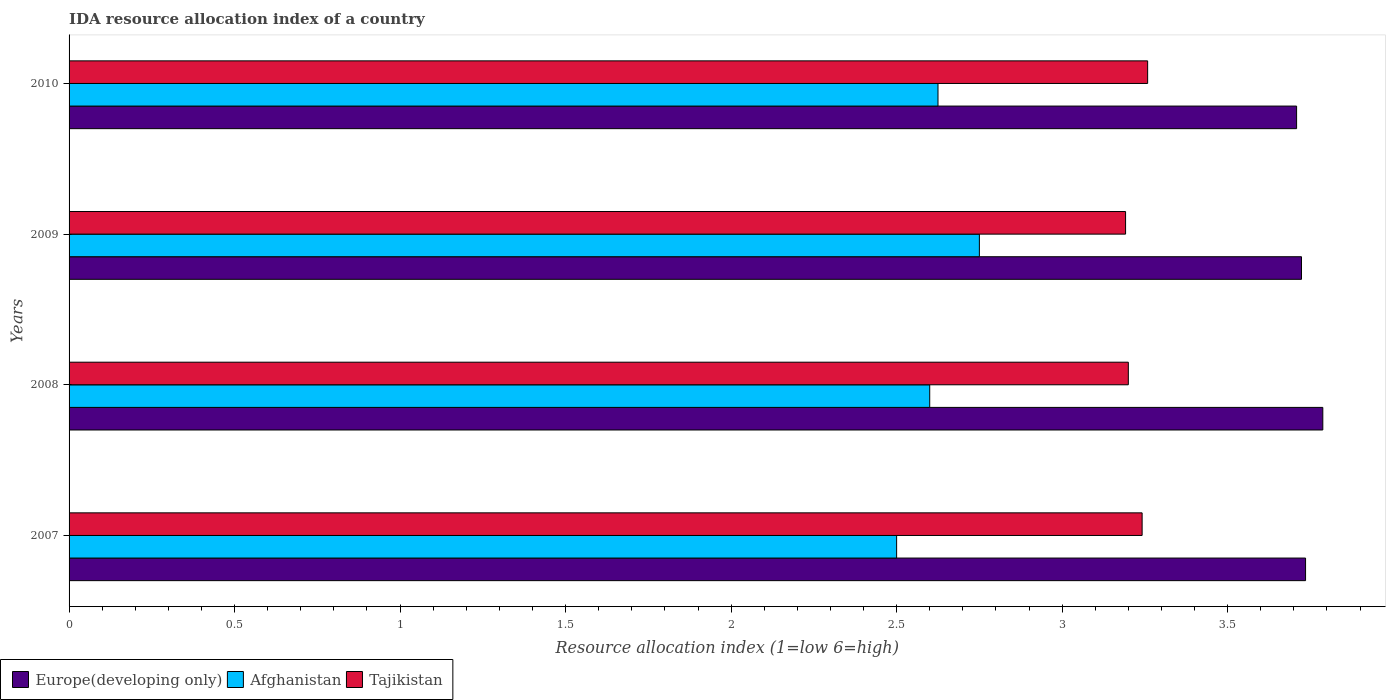How many bars are there on the 4th tick from the top?
Provide a succinct answer. 3. What is the IDA resource allocation index in Afghanistan in 2010?
Offer a very short reply. 2.62. Across all years, what is the maximum IDA resource allocation index in Tajikistan?
Keep it short and to the point. 3.26. In which year was the IDA resource allocation index in Europe(developing only) maximum?
Make the answer very short. 2008. In which year was the IDA resource allocation index in Europe(developing only) minimum?
Make the answer very short. 2010. What is the total IDA resource allocation index in Europe(developing only) in the graph?
Offer a very short reply. 14.95. What is the difference between the IDA resource allocation index in Europe(developing only) in 2007 and that in 2010?
Make the answer very short. 0.03. What is the difference between the IDA resource allocation index in Europe(developing only) in 2009 and the IDA resource allocation index in Tajikistan in 2008?
Give a very brief answer. 0.52. What is the average IDA resource allocation index in Europe(developing only) per year?
Give a very brief answer. 3.74. In the year 2007, what is the difference between the IDA resource allocation index in Tajikistan and IDA resource allocation index in Europe(developing only)?
Your answer should be compact. -0.49. In how many years, is the IDA resource allocation index in Afghanistan greater than 0.30000000000000004 ?
Keep it short and to the point. 4. What is the ratio of the IDA resource allocation index in Europe(developing only) in 2008 to that in 2009?
Provide a short and direct response. 1.02. Is the IDA resource allocation index in Tajikistan in 2008 less than that in 2009?
Provide a short and direct response. No. Is the difference between the IDA resource allocation index in Tajikistan in 2008 and 2010 greater than the difference between the IDA resource allocation index in Europe(developing only) in 2008 and 2010?
Your answer should be compact. No. What is the difference between the highest and the second highest IDA resource allocation index in Tajikistan?
Ensure brevity in your answer.  0.02. What is the difference between the highest and the lowest IDA resource allocation index in Europe(developing only)?
Make the answer very short. 0.08. In how many years, is the IDA resource allocation index in Afghanistan greater than the average IDA resource allocation index in Afghanistan taken over all years?
Give a very brief answer. 2. What does the 1st bar from the top in 2008 represents?
Your response must be concise. Tajikistan. What does the 2nd bar from the bottom in 2010 represents?
Your response must be concise. Afghanistan. Is it the case that in every year, the sum of the IDA resource allocation index in Tajikistan and IDA resource allocation index in Afghanistan is greater than the IDA resource allocation index in Europe(developing only)?
Your answer should be compact. Yes. How many bars are there?
Offer a very short reply. 12. Are all the bars in the graph horizontal?
Provide a short and direct response. Yes. How are the legend labels stacked?
Offer a very short reply. Horizontal. What is the title of the graph?
Keep it short and to the point. IDA resource allocation index of a country. Does "Australia" appear as one of the legend labels in the graph?
Offer a very short reply. No. What is the label or title of the X-axis?
Your answer should be very brief. Resource allocation index (1=low 6=high). What is the Resource allocation index (1=low 6=high) of Europe(developing only) in 2007?
Your response must be concise. 3.74. What is the Resource allocation index (1=low 6=high) of Tajikistan in 2007?
Provide a succinct answer. 3.24. What is the Resource allocation index (1=low 6=high) of Europe(developing only) in 2008?
Offer a very short reply. 3.79. What is the Resource allocation index (1=low 6=high) in Afghanistan in 2008?
Make the answer very short. 2.6. What is the Resource allocation index (1=low 6=high) of Europe(developing only) in 2009?
Offer a terse response. 3.72. What is the Resource allocation index (1=low 6=high) of Afghanistan in 2009?
Provide a succinct answer. 2.75. What is the Resource allocation index (1=low 6=high) of Tajikistan in 2009?
Provide a succinct answer. 3.19. What is the Resource allocation index (1=low 6=high) in Europe(developing only) in 2010?
Your answer should be compact. 3.71. What is the Resource allocation index (1=low 6=high) of Afghanistan in 2010?
Your answer should be compact. 2.62. What is the Resource allocation index (1=low 6=high) of Tajikistan in 2010?
Ensure brevity in your answer.  3.26. Across all years, what is the maximum Resource allocation index (1=low 6=high) of Europe(developing only)?
Ensure brevity in your answer.  3.79. Across all years, what is the maximum Resource allocation index (1=low 6=high) of Afghanistan?
Your response must be concise. 2.75. Across all years, what is the maximum Resource allocation index (1=low 6=high) of Tajikistan?
Your answer should be very brief. 3.26. Across all years, what is the minimum Resource allocation index (1=low 6=high) in Europe(developing only)?
Offer a very short reply. 3.71. Across all years, what is the minimum Resource allocation index (1=low 6=high) in Afghanistan?
Your response must be concise. 2.5. Across all years, what is the minimum Resource allocation index (1=low 6=high) in Tajikistan?
Keep it short and to the point. 3.19. What is the total Resource allocation index (1=low 6=high) of Europe(developing only) in the graph?
Make the answer very short. 14.95. What is the total Resource allocation index (1=low 6=high) of Afghanistan in the graph?
Offer a very short reply. 10.47. What is the total Resource allocation index (1=low 6=high) in Tajikistan in the graph?
Keep it short and to the point. 12.89. What is the difference between the Resource allocation index (1=low 6=high) in Europe(developing only) in 2007 and that in 2008?
Your answer should be compact. -0.05. What is the difference between the Resource allocation index (1=low 6=high) of Afghanistan in 2007 and that in 2008?
Your answer should be very brief. -0.1. What is the difference between the Resource allocation index (1=low 6=high) of Tajikistan in 2007 and that in 2008?
Your response must be concise. 0.04. What is the difference between the Resource allocation index (1=low 6=high) of Europe(developing only) in 2007 and that in 2009?
Provide a succinct answer. 0.01. What is the difference between the Resource allocation index (1=low 6=high) of Afghanistan in 2007 and that in 2009?
Provide a succinct answer. -0.25. What is the difference between the Resource allocation index (1=low 6=high) in Europe(developing only) in 2007 and that in 2010?
Provide a succinct answer. 0.03. What is the difference between the Resource allocation index (1=low 6=high) of Afghanistan in 2007 and that in 2010?
Ensure brevity in your answer.  -0.12. What is the difference between the Resource allocation index (1=low 6=high) in Tajikistan in 2007 and that in 2010?
Ensure brevity in your answer.  -0.02. What is the difference between the Resource allocation index (1=low 6=high) in Europe(developing only) in 2008 and that in 2009?
Your answer should be very brief. 0.06. What is the difference between the Resource allocation index (1=low 6=high) in Tajikistan in 2008 and that in 2009?
Offer a very short reply. 0.01. What is the difference between the Resource allocation index (1=low 6=high) in Europe(developing only) in 2008 and that in 2010?
Make the answer very short. 0.08. What is the difference between the Resource allocation index (1=low 6=high) of Afghanistan in 2008 and that in 2010?
Offer a very short reply. -0.03. What is the difference between the Resource allocation index (1=low 6=high) of Tajikistan in 2008 and that in 2010?
Ensure brevity in your answer.  -0.06. What is the difference between the Resource allocation index (1=low 6=high) in Europe(developing only) in 2009 and that in 2010?
Offer a terse response. 0.01. What is the difference between the Resource allocation index (1=low 6=high) of Tajikistan in 2009 and that in 2010?
Offer a terse response. -0.07. What is the difference between the Resource allocation index (1=low 6=high) of Europe(developing only) in 2007 and the Resource allocation index (1=low 6=high) of Afghanistan in 2008?
Make the answer very short. 1.14. What is the difference between the Resource allocation index (1=low 6=high) in Europe(developing only) in 2007 and the Resource allocation index (1=low 6=high) in Tajikistan in 2008?
Your answer should be very brief. 0.54. What is the difference between the Resource allocation index (1=low 6=high) of Afghanistan in 2007 and the Resource allocation index (1=low 6=high) of Tajikistan in 2008?
Give a very brief answer. -0.7. What is the difference between the Resource allocation index (1=low 6=high) in Europe(developing only) in 2007 and the Resource allocation index (1=low 6=high) in Afghanistan in 2009?
Provide a short and direct response. 0.99. What is the difference between the Resource allocation index (1=low 6=high) of Europe(developing only) in 2007 and the Resource allocation index (1=low 6=high) of Tajikistan in 2009?
Your answer should be compact. 0.54. What is the difference between the Resource allocation index (1=low 6=high) of Afghanistan in 2007 and the Resource allocation index (1=low 6=high) of Tajikistan in 2009?
Your response must be concise. -0.69. What is the difference between the Resource allocation index (1=low 6=high) in Europe(developing only) in 2007 and the Resource allocation index (1=low 6=high) in Afghanistan in 2010?
Your answer should be compact. 1.11. What is the difference between the Resource allocation index (1=low 6=high) of Europe(developing only) in 2007 and the Resource allocation index (1=low 6=high) of Tajikistan in 2010?
Offer a very short reply. 0.48. What is the difference between the Resource allocation index (1=low 6=high) in Afghanistan in 2007 and the Resource allocation index (1=low 6=high) in Tajikistan in 2010?
Your answer should be compact. -0.76. What is the difference between the Resource allocation index (1=low 6=high) of Europe(developing only) in 2008 and the Resource allocation index (1=low 6=high) of Afghanistan in 2009?
Make the answer very short. 1.04. What is the difference between the Resource allocation index (1=low 6=high) of Europe(developing only) in 2008 and the Resource allocation index (1=low 6=high) of Tajikistan in 2009?
Offer a very short reply. 0.6. What is the difference between the Resource allocation index (1=low 6=high) in Afghanistan in 2008 and the Resource allocation index (1=low 6=high) in Tajikistan in 2009?
Your answer should be very brief. -0.59. What is the difference between the Resource allocation index (1=low 6=high) in Europe(developing only) in 2008 and the Resource allocation index (1=low 6=high) in Afghanistan in 2010?
Keep it short and to the point. 1.16. What is the difference between the Resource allocation index (1=low 6=high) of Europe(developing only) in 2008 and the Resource allocation index (1=low 6=high) of Tajikistan in 2010?
Ensure brevity in your answer.  0.53. What is the difference between the Resource allocation index (1=low 6=high) of Afghanistan in 2008 and the Resource allocation index (1=low 6=high) of Tajikistan in 2010?
Ensure brevity in your answer.  -0.66. What is the difference between the Resource allocation index (1=low 6=high) in Europe(developing only) in 2009 and the Resource allocation index (1=low 6=high) in Afghanistan in 2010?
Your answer should be compact. 1.1. What is the difference between the Resource allocation index (1=low 6=high) of Europe(developing only) in 2009 and the Resource allocation index (1=low 6=high) of Tajikistan in 2010?
Offer a terse response. 0.46. What is the difference between the Resource allocation index (1=low 6=high) in Afghanistan in 2009 and the Resource allocation index (1=low 6=high) in Tajikistan in 2010?
Keep it short and to the point. -0.51. What is the average Resource allocation index (1=low 6=high) in Europe(developing only) per year?
Offer a terse response. 3.74. What is the average Resource allocation index (1=low 6=high) of Afghanistan per year?
Your answer should be very brief. 2.62. What is the average Resource allocation index (1=low 6=high) in Tajikistan per year?
Offer a terse response. 3.22. In the year 2007, what is the difference between the Resource allocation index (1=low 6=high) in Europe(developing only) and Resource allocation index (1=low 6=high) in Afghanistan?
Your answer should be compact. 1.24. In the year 2007, what is the difference between the Resource allocation index (1=low 6=high) in Europe(developing only) and Resource allocation index (1=low 6=high) in Tajikistan?
Keep it short and to the point. 0.49. In the year 2007, what is the difference between the Resource allocation index (1=low 6=high) in Afghanistan and Resource allocation index (1=low 6=high) in Tajikistan?
Keep it short and to the point. -0.74. In the year 2008, what is the difference between the Resource allocation index (1=low 6=high) of Europe(developing only) and Resource allocation index (1=low 6=high) of Afghanistan?
Keep it short and to the point. 1.19. In the year 2008, what is the difference between the Resource allocation index (1=low 6=high) in Europe(developing only) and Resource allocation index (1=low 6=high) in Tajikistan?
Make the answer very short. 0.59. In the year 2008, what is the difference between the Resource allocation index (1=low 6=high) in Afghanistan and Resource allocation index (1=low 6=high) in Tajikistan?
Your response must be concise. -0.6. In the year 2009, what is the difference between the Resource allocation index (1=low 6=high) of Europe(developing only) and Resource allocation index (1=low 6=high) of Afghanistan?
Provide a succinct answer. 0.97. In the year 2009, what is the difference between the Resource allocation index (1=low 6=high) in Europe(developing only) and Resource allocation index (1=low 6=high) in Tajikistan?
Provide a succinct answer. 0.53. In the year 2009, what is the difference between the Resource allocation index (1=low 6=high) in Afghanistan and Resource allocation index (1=low 6=high) in Tajikistan?
Your response must be concise. -0.44. In the year 2010, what is the difference between the Resource allocation index (1=low 6=high) in Europe(developing only) and Resource allocation index (1=low 6=high) in Tajikistan?
Your response must be concise. 0.45. In the year 2010, what is the difference between the Resource allocation index (1=low 6=high) in Afghanistan and Resource allocation index (1=low 6=high) in Tajikistan?
Offer a terse response. -0.63. What is the ratio of the Resource allocation index (1=low 6=high) of Europe(developing only) in 2007 to that in 2008?
Offer a very short reply. 0.99. What is the ratio of the Resource allocation index (1=low 6=high) of Afghanistan in 2007 to that in 2008?
Keep it short and to the point. 0.96. What is the ratio of the Resource allocation index (1=low 6=high) of Tajikistan in 2007 to that in 2008?
Ensure brevity in your answer.  1.01. What is the ratio of the Resource allocation index (1=low 6=high) in Europe(developing only) in 2007 to that in 2009?
Make the answer very short. 1. What is the ratio of the Resource allocation index (1=low 6=high) in Afghanistan in 2007 to that in 2009?
Offer a terse response. 0.91. What is the ratio of the Resource allocation index (1=low 6=high) of Tajikistan in 2007 to that in 2009?
Your response must be concise. 1.02. What is the ratio of the Resource allocation index (1=low 6=high) in Europe(developing only) in 2007 to that in 2010?
Provide a succinct answer. 1.01. What is the ratio of the Resource allocation index (1=low 6=high) of Afghanistan in 2007 to that in 2010?
Make the answer very short. 0.95. What is the ratio of the Resource allocation index (1=low 6=high) in Tajikistan in 2007 to that in 2010?
Provide a short and direct response. 0.99. What is the ratio of the Resource allocation index (1=low 6=high) of Europe(developing only) in 2008 to that in 2009?
Ensure brevity in your answer.  1.02. What is the ratio of the Resource allocation index (1=low 6=high) in Afghanistan in 2008 to that in 2009?
Ensure brevity in your answer.  0.95. What is the ratio of the Resource allocation index (1=low 6=high) in Tajikistan in 2008 to that in 2009?
Your answer should be very brief. 1. What is the ratio of the Resource allocation index (1=low 6=high) in Europe(developing only) in 2008 to that in 2010?
Your answer should be compact. 1.02. What is the ratio of the Resource allocation index (1=low 6=high) in Tajikistan in 2008 to that in 2010?
Offer a terse response. 0.98. What is the ratio of the Resource allocation index (1=low 6=high) of Europe(developing only) in 2009 to that in 2010?
Offer a terse response. 1. What is the ratio of the Resource allocation index (1=low 6=high) in Afghanistan in 2009 to that in 2010?
Your response must be concise. 1.05. What is the ratio of the Resource allocation index (1=low 6=high) in Tajikistan in 2009 to that in 2010?
Your response must be concise. 0.98. What is the difference between the highest and the second highest Resource allocation index (1=low 6=high) of Europe(developing only)?
Your answer should be very brief. 0.05. What is the difference between the highest and the second highest Resource allocation index (1=low 6=high) in Afghanistan?
Your answer should be compact. 0.12. What is the difference between the highest and the second highest Resource allocation index (1=low 6=high) of Tajikistan?
Give a very brief answer. 0.02. What is the difference between the highest and the lowest Resource allocation index (1=low 6=high) of Europe(developing only)?
Your answer should be very brief. 0.08. What is the difference between the highest and the lowest Resource allocation index (1=low 6=high) of Afghanistan?
Offer a very short reply. 0.25. What is the difference between the highest and the lowest Resource allocation index (1=low 6=high) in Tajikistan?
Offer a terse response. 0.07. 